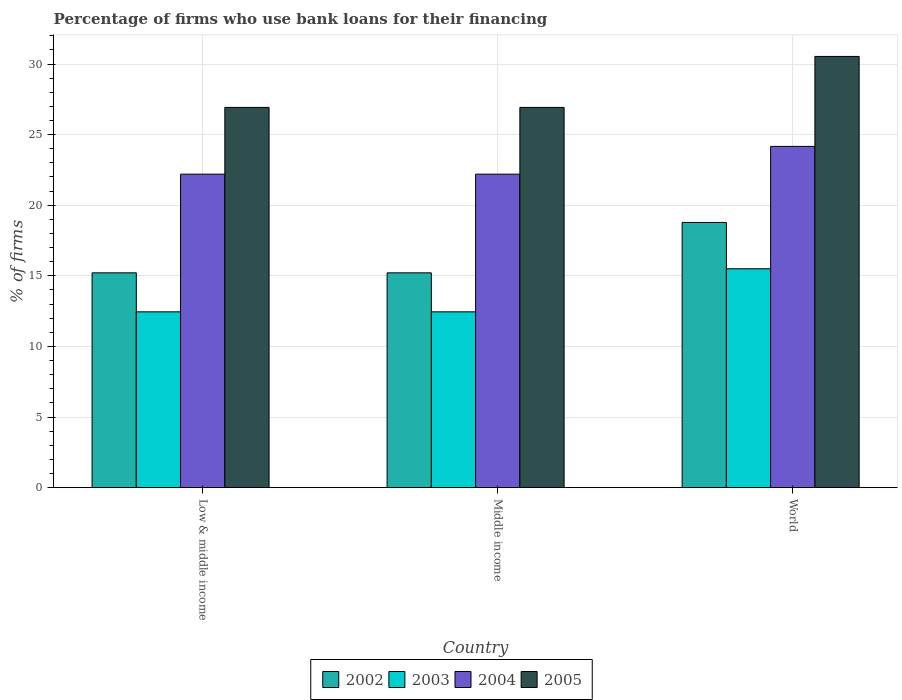How many different coloured bars are there?
Make the answer very short. 4. Are the number of bars on each tick of the X-axis equal?
Make the answer very short. Yes. What is the label of the 3rd group of bars from the left?
Keep it short and to the point. World. What is the percentage of firms who use bank loans for their financing in 2005 in World?
Your response must be concise. 30.54. Across all countries, what is the maximum percentage of firms who use bank loans for their financing in 2005?
Ensure brevity in your answer.  30.54. Across all countries, what is the minimum percentage of firms who use bank loans for their financing in 2002?
Your answer should be very brief. 15.21. In which country was the percentage of firms who use bank loans for their financing in 2003 maximum?
Your answer should be compact. World. What is the total percentage of firms who use bank loans for their financing in 2002 in the graph?
Provide a succinct answer. 49.21. What is the difference between the percentage of firms who use bank loans for their financing in 2005 in Low & middle income and the percentage of firms who use bank loans for their financing in 2004 in Middle income?
Your answer should be compact. 4.73. What is the average percentage of firms who use bank loans for their financing in 2005 per country?
Your response must be concise. 28.13. What is the difference between the percentage of firms who use bank loans for their financing of/in 2003 and percentage of firms who use bank loans for their financing of/in 2005 in Middle income?
Give a very brief answer. -14.48. What is the ratio of the percentage of firms who use bank loans for their financing in 2002 in Middle income to that in World?
Offer a terse response. 0.81. Is the difference between the percentage of firms who use bank loans for their financing in 2003 in Low & middle income and World greater than the difference between the percentage of firms who use bank loans for their financing in 2005 in Low & middle income and World?
Offer a very short reply. Yes. What is the difference between the highest and the second highest percentage of firms who use bank loans for their financing in 2005?
Your answer should be very brief. -3.61. What is the difference between the highest and the lowest percentage of firms who use bank loans for their financing in 2003?
Your answer should be compact. 3.05. Is the sum of the percentage of firms who use bank loans for their financing in 2005 in Middle income and World greater than the maximum percentage of firms who use bank loans for their financing in 2004 across all countries?
Your answer should be very brief. Yes. What does the 3rd bar from the right in Middle income represents?
Your answer should be compact. 2003. What is the difference between two consecutive major ticks on the Y-axis?
Provide a succinct answer. 5. Where does the legend appear in the graph?
Your answer should be very brief. Bottom center. How many legend labels are there?
Keep it short and to the point. 4. How are the legend labels stacked?
Provide a succinct answer. Horizontal. What is the title of the graph?
Your answer should be compact. Percentage of firms who use bank loans for their financing. Does "1995" appear as one of the legend labels in the graph?
Your answer should be very brief. No. What is the label or title of the Y-axis?
Your answer should be compact. % of firms. What is the % of firms in 2002 in Low & middle income?
Offer a very short reply. 15.21. What is the % of firms of 2003 in Low & middle income?
Your response must be concise. 12.45. What is the % of firms of 2004 in Low & middle income?
Your answer should be very brief. 22.2. What is the % of firms in 2005 in Low & middle income?
Ensure brevity in your answer.  26.93. What is the % of firms in 2002 in Middle income?
Ensure brevity in your answer.  15.21. What is the % of firms in 2003 in Middle income?
Give a very brief answer. 12.45. What is the % of firms of 2005 in Middle income?
Ensure brevity in your answer.  26.93. What is the % of firms of 2002 in World?
Provide a succinct answer. 18.78. What is the % of firms of 2004 in World?
Keep it short and to the point. 24.17. What is the % of firms in 2005 in World?
Your answer should be compact. 30.54. Across all countries, what is the maximum % of firms in 2002?
Ensure brevity in your answer.  18.78. Across all countries, what is the maximum % of firms in 2003?
Provide a short and direct response. 15.5. Across all countries, what is the maximum % of firms of 2004?
Your answer should be compact. 24.17. Across all countries, what is the maximum % of firms in 2005?
Provide a short and direct response. 30.54. Across all countries, what is the minimum % of firms of 2002?
Your response must be concise. 15.21. Across all countries, what is the minimum % of firms in 2003?
Offer a terse response. 12.45. Across all countries, what is the minimum % of firms of 2005?
Keep it short and to the point. 26.93. What is the total % of firms of 2002 in the graph?
Offer a terse response. 49.21. What is the total % of firms of 2003 in the graph?
Your response must be concise. 40.4. What is the total % of firms in 2004 in the graph?
Your answer should be compact. 68.57. What is the total % of firms of 2005 in the graph?
Ensure brevity in your answer.  84.39. What is the difference between the % of firms in 2002 in Low & middle income and that in Middle income?
Provide a short and direct response. 0. What is the difference between the % of firms of 2002 in Low & middle income and that in World?
Your response must be concise. -3.57. What is the difference between the % of firms in 2003 in Low & middle income and that in World?
Keep it short and to the point. -3.05. What is the difference between the % of firms in 2004 in Low & middle income and that in World?
Your answer should be very brief. -1.97. What is the difference between the % of firms of 2005 in Low & middle income and that in World?
Offer a terse response. -3.61. What is the difference between the % of firms of 2002 in Middle income and that in World?
Ensure brevity in your answer.  -3.57. What is the difference between the % of firms in 2003 in Middle income and that in World?
Provide a short and direct response. -3.05. What is the difference between the % of firms in 2004 in Middle income and that in World?
Provide a short and direct response. -1.97. What is the difference between the % of firms in 2005 in Middle income and that in World?
Give a very brief answer. -3.61. What is the difference between the % of firms of 2002 in Low & middle income and the % of firms of 2003 in Middle income?
Provide a short and direct response. 2.76. What is the difference between the % of firms of 2002 in Low & middle income and the % of firms of 2004 in Middle income?
Make the answer very short. -6.99. What is the difference between the % of firms in 2002 in Low & middle income and the % of firms in 2005 in Middle income?
Your response must be concise. -11.72. What is the difference between the % of firms of 2003 in Low & middle income and the % of firms of 2004 in Middle income?
Keep it short and to the point. -9.75. What is the difference between the % of firms in 2003 in Low & middle income and the % of firms in 2005 in Middle income?
Provide a short and direct response. -14.48. What is the difference between the % of firms in 2004 in Low & middle income and the % of firms in 2005 in Middle income?
Make the answer very short. -4.73. What is the difference between the % of firms of 2002 in Low & middle income and the % of firms of 2003 in World?
Offer a very short reply. -0.29. What is the difference between the % of firms in 2002 in Low & middle income and the % of firms in 2004 in World?
Give a very brief answer. -8.95. What is the difference between the % of firms in 2002 in Low & middle income and the % of firms in 2005 in World?
Give a very brief answer. -15.33. What is the difference between the % of firms in 2003 in Low & middle income and the % of firms in 2004 in World?
Provide a short and direct response. -11.72. What is the difference between the % of firms in 2003 in Low & middle income and the % of firms in 2005 in World?
Your answer should be compact. -18.09. What is the difference between the % of firms in 2004 in Low & middle income and the % of firms in 2005 in World?
Give a very brief answer. -8.34. What is the difference between the % of firms of 2002 in Middle income and the % of firms of 2003 in World?
Provide a short and direct response. -0.29. What is the difference between the % of firms in 2002 in Middle income and the % of firms in 2004 in World?
Give a very brief answer. -8.95. What is the difference between the % of firms of 2002 in Middle income and the % of firms of 2005 in World?
Ensure brevity in your answer.  -15.33. What is the difference between the % of firms in 2003 in Middle income and the % of firms in 2004 in World?
Give a very brief answer. -11.72. What is the difference between the % of firms of 2003 in Middle income and the % of firms of 2005 in World?
Your answer should be compact. -18.09. What is the difference between the % of firms of 2004 in Middle income and the % of firms of 2005 in World?
Give a very brief answer. -8.34. What is the average % of firms in 2002 per country?
Make the answer very short. 16.4. What is the average % of firms of 2003 per country?
Offer a very short reply. 13.47. What is the average % of firms in 2004 per country?
Give a very brief answer. 22.86. What is the average % of firms in 2005 per country?
Your answer should be very brief. 28.13. What is the difference between the % of firms of 2002 and % of firms of 2003 in Low & middle income?
Ensure brevity in your answer.  2.76. What is the difference between the % of firms of 2002 and % of firms of 2004 in Low & middle income?
Make the answer very short. -6.99. What is the difference between the % of firms in 2002 and % of firms in 2005 in Low & middle income?
Your answer should be compact. -11.72. What is the difference between the % of firms in 2003 and % of firms in 2004 in Low & middle income?
Your answer should be compact. -9.75. What is the difference between the % of firms in 2003 and % of firms in 2005 in Low & middle income?
Offer a very short reply. -14.48. What is the difference between the % of firms in 2004 and % of firms in 2005 in Low & middle income?
Offer a very short reply. -4.73. What is the difference between the % of firms in 2002 and % of firms in 2003 in Middle income?
Your answer should be very brief. 2.76. What is the difference between the % of firms in 2002 and % of firms in 2004 in Middle income?
Provide a succinct answer. -6.99. What is the difference between the % of firms of 2002 and % of firms of 2005 in Middle income?
Offer a terse response. -11.72. What is the difference between the % of firms in 2003 and % of firms in 2004 in Middle income?
Your answer should be compact. -9.75. What is the difference between the % of firms of 2003 and % of firms of 2005 in Middle income?
Offer a very short reply. -14.48. What is the difference between the % of firms of 2004 and % of firms of 2005 in Middle income?
Make the answer very short. -4.73. What is the difference between the % of firms of 2002 and % of firms of 2003 in World?
Your answer should be very brief. 3.28. What is the difference between the % of firms in 2002 and % of firms in 2004 in World?
Offer a very short reply. -5.39. What is the difference between the % of firms of 2002 and % of firms of 2005 in World?
Keep it short and to the point. -11.76. What is the difference between the % of firms of 2003 and % of firms of 2004 in World?
Offer a very short reply. -8.67. What is the difference between the % of firms of 2003 and % of firms of 2005 in World?
Provide a succinct answer. -15.04. What is the difference between the % of firms in 2004 and % of firms in 2005 in World?
Your response must be concise. -6.37. What is the ratio of the % of firms of 2003 in Low & middle income to that in Middle income?
Give a very brief answer. 1. What is the ratio of the % of firms of 2004 in Low & middle income to that in Middle income?
Provide a short and direct response. 1. What is the ratio of the % of firms in 2005 in Low & middle income to that in Middle income?
Keep it short and to the point. 1. What is the ratio of the % of firms in 2002 in Low & middle income to that in World?
Make the answer very short. 0.81. What is the ratio of the % of firms in 2003 in Low & middle income to that in World?
Make the answer very short. 0.8. What is the ratio of the % of firms in 2004 in Low & middle income to that in World?
Ensure brevity in your answer.  0.92. What is the ratio of the % of firms in 2005 in Low & middle income to that in World?
Keep it short and to the point. 0.88. What is the ratio of the % of firms of 2002 in Middle income to that in World?
Your answer should be very brief. 0.81. What is the ratio of the % of firms in 2003 in Middle income to that in World?
Provide a short and direct response. 0.8. What is the ratio of the % of firms of 2004 in Middle income to that in World?
Provide a short and direct response. 0.92. What is the ratio of the % of firms in 2005 in Middle income to that in World?
Provide a succinct answer. 0.88. What is the difference between the highest and the second highest % of firms in 2002?
Provide a short and direct response. 3.57. What is the difference between the highest and the second highest % of firms in 2003?
Give a very brief answer. 3.05. What is the difference between the highest and the second highest % of firms of 2004?
Make the answer very short. 1.97. What is the difference between the highest and the second highest % of firms of 2005?
Provide a succinct answer. 3.61. What is the difference between the highest and the lowest % of firms in 2002?
Ensure brevity in your answer.  3.57. What is the difference between the highest and the lowest % of firms in 2003?
Your response must be concise. 3.05. What is the difference between the highest and the lowest % of firms of 2004?
Offer a very short reply. 1.97. What is the difference between the highest and the lowest % of firms of 2005?
Provide a short and direct response. 3.61. 